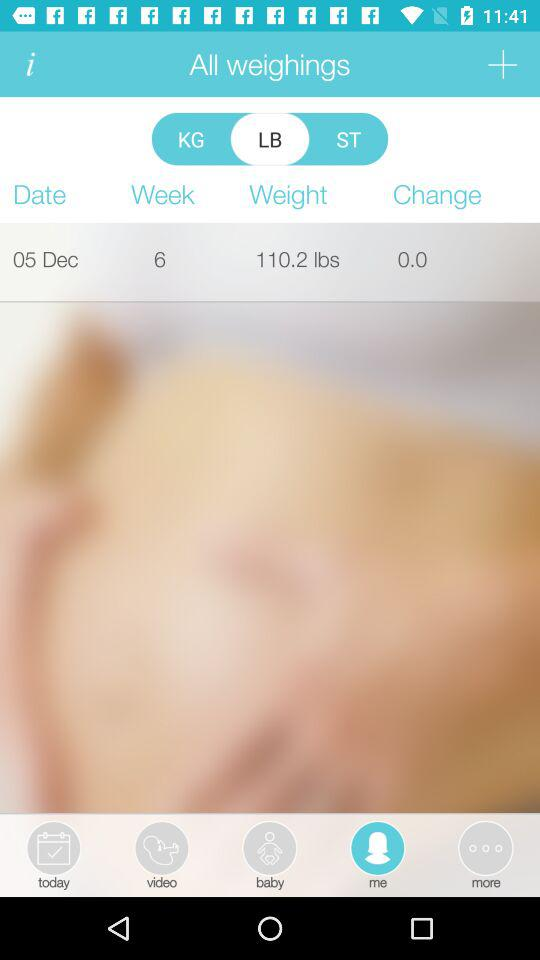What is the current week number? The current week number is 6. 